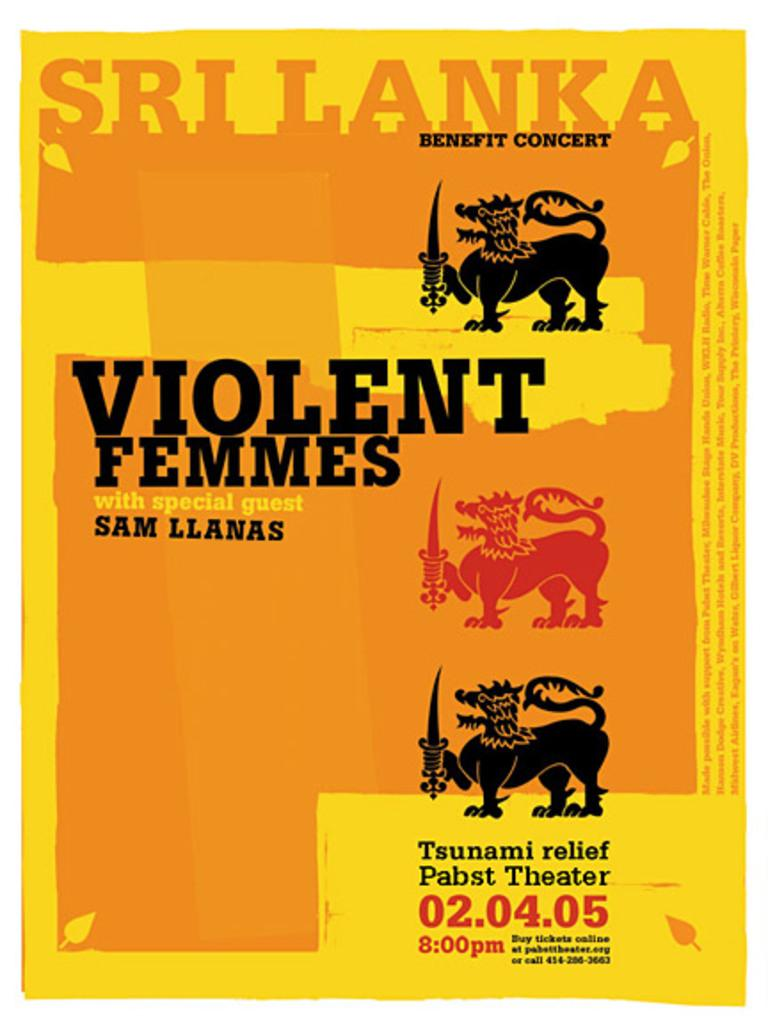What is featured on the poster in the image? The poster depicts animals holding swords. Are there any additional elements on the poster besides the animals and swords? Yes, the poster has leaves on it and text. Are there any numbers on the poster? Yes, there are numbers on the poster. What type of jam is being spread on the furniture in the image? There is no jam or furniture present in the image; it only features a poster with animals holding swords. 